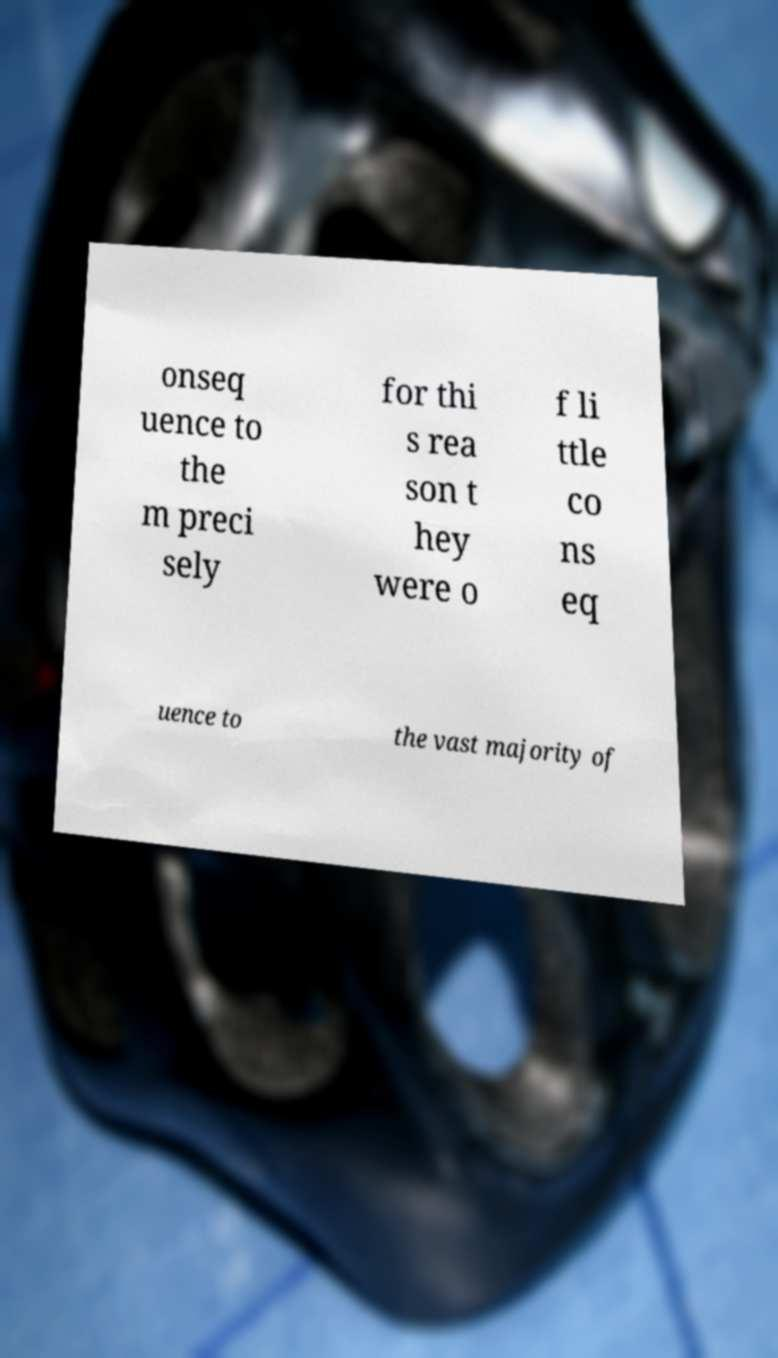Please identify and transcribe the text found in this image. onseq uence to the m preci sely for thi s rea son t hey were o f li ttle co ns eq uence to the vast majority of 